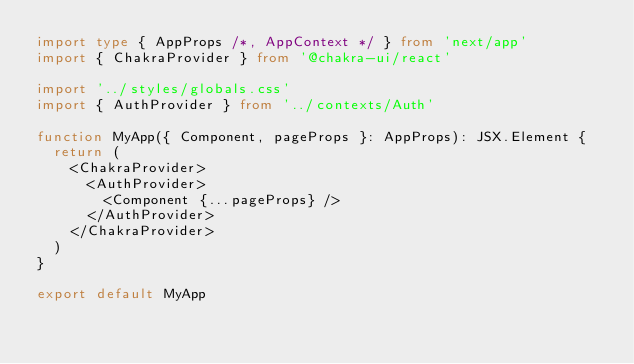Convert code to text. <code><loc_0><loc_0><loc_500><loc_500><_TypeScript_>import type { AppProps /*, AppContext */ } from 'next/app'
import { ChakraProvider } from '@chakra-ui/react'

import '../styles/globals.css'
import { AuthProvider } from '../contexts/Auth'

function MyApp({ Component, pageProps }: AppProps): JSX.Element {
  return (
    <ChakraProvider>
      <AuthProvider>
        <Component {...pageProps} />
      </AuthProvider>
    </ChakraProvider>
  )
}

export default MyApp
</code> 